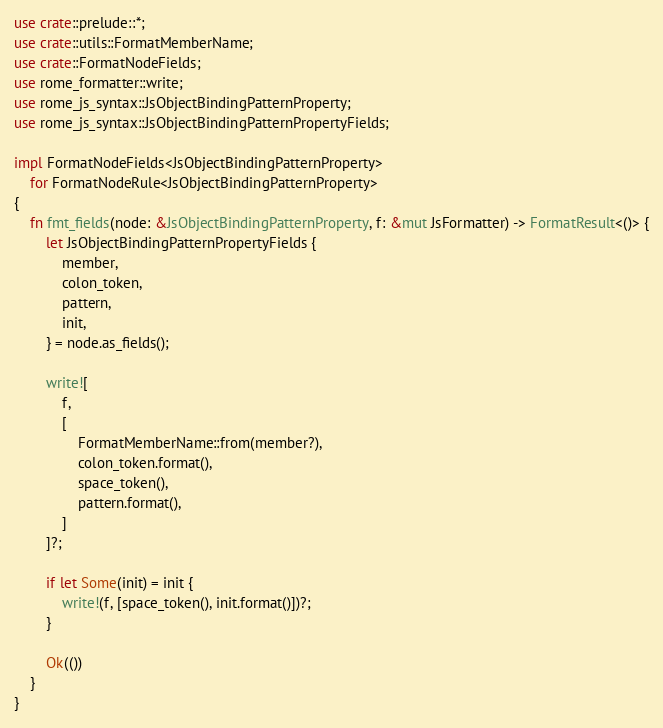<code> <loc_0><loc_0><loc_500><loc_500><_Rust_>use crate::prelude::*;
use crate::utils::FormatMemberName;
use crate::FormatNodeFields;
use rome_formatter::write;
use rome_js_syntax::JsObjectBindingPatternProperty;
use rome_js_syntax::JsObjectBindingPatternPropertyFields;

impl FormatNodeFields<JsObjectBindingPatternProperty>
    for FormatNodeRule<JsObjectBindingPatternProperty>
{
    fn fmt_fields(node: &JsObjectBindingPatternProperty, f: &mut JsFormatter) -> FormatResult<()> {
        let JsObjectBindingPatternPropertyFields {
            member,
            colon_token,
            pattern,
            init,
        } = node.as_fields();

        write![
            f,
            [
                FormatMemberName::from(member?),
                colon_token.format(),
                space_token(),
                pattern.format(),
            ]
        ]?;

        if let Some(init) = init {
            write!(f, [space_token(), init.format()])?;
        }

        Ok(())
    }
}
</code> 